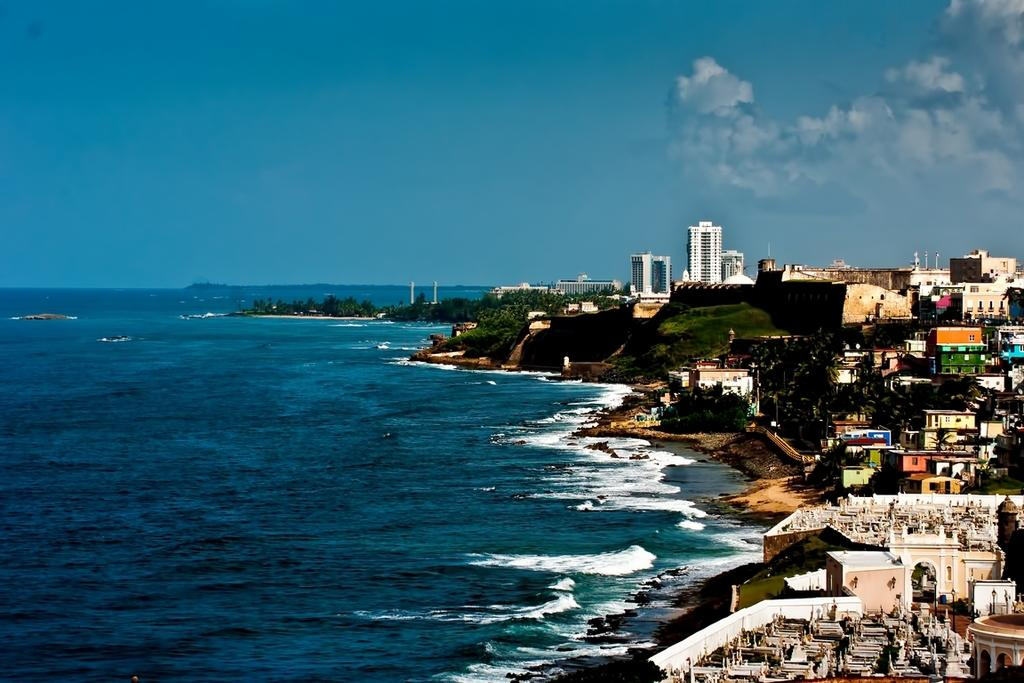What type of structures can be seen in the image? There are buildings with windows in the image. What natural elements are present in the image? There are trees and water visible in the image. What type of ground cover is present in the image? There is grass in the image. What can be seen in the background of the image? The sky with clouds is visible in the background of the image. Who is the creator of the trees in the image? The image does not provide information about the creator of the trees; trees are a natural element and grow on their own. 